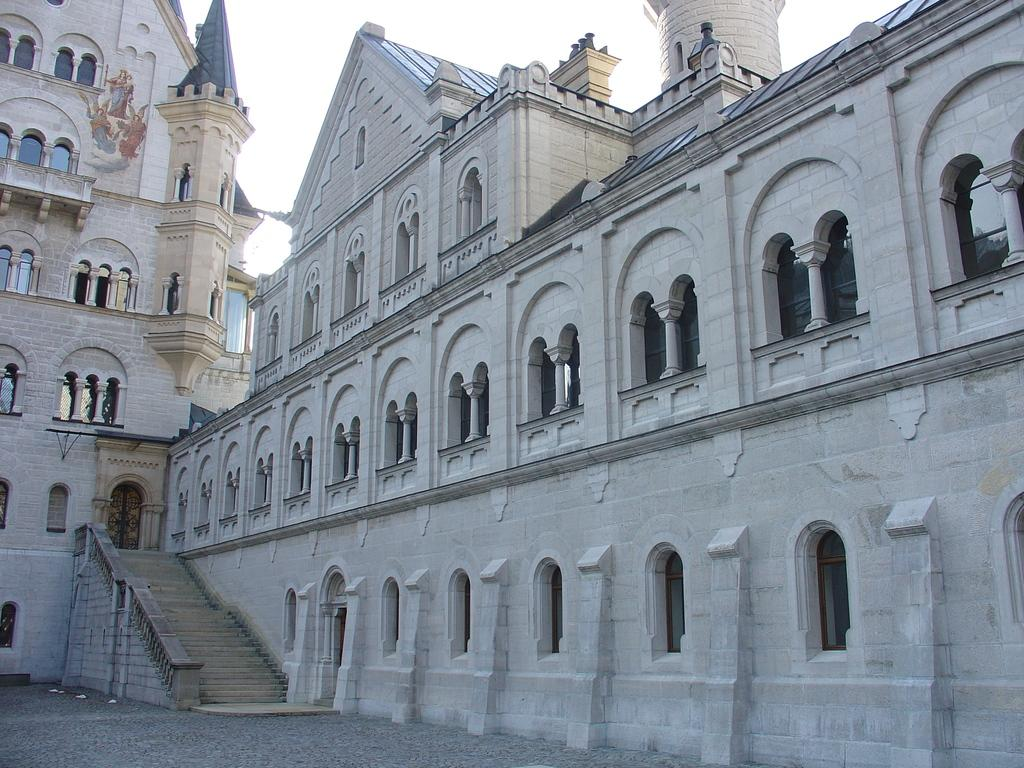What is the main subject of the image? There is a building in the center of the image. Can you describe the building in the image? Unfortunately, the provided facts do not include any details about the building's appearance or features. Is there any other significant object or structure in the image? The facts only mention the building, so there is no other significant object or structure mentioned. What rhythm is the building playing in the image? Buildings do not play rhythms, as they are inanimate structures. 